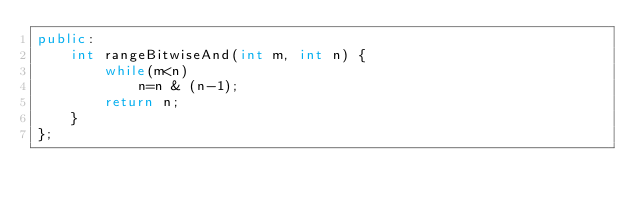Convert code to text. <code><loc_0><loc_0><loc_500><loc_500><_C++_>public:
    int rangeBitwiseAnd(int m, int n) {
        while(m<n)
            n=n & (n-1);
        return n;
    }
};
</code> 